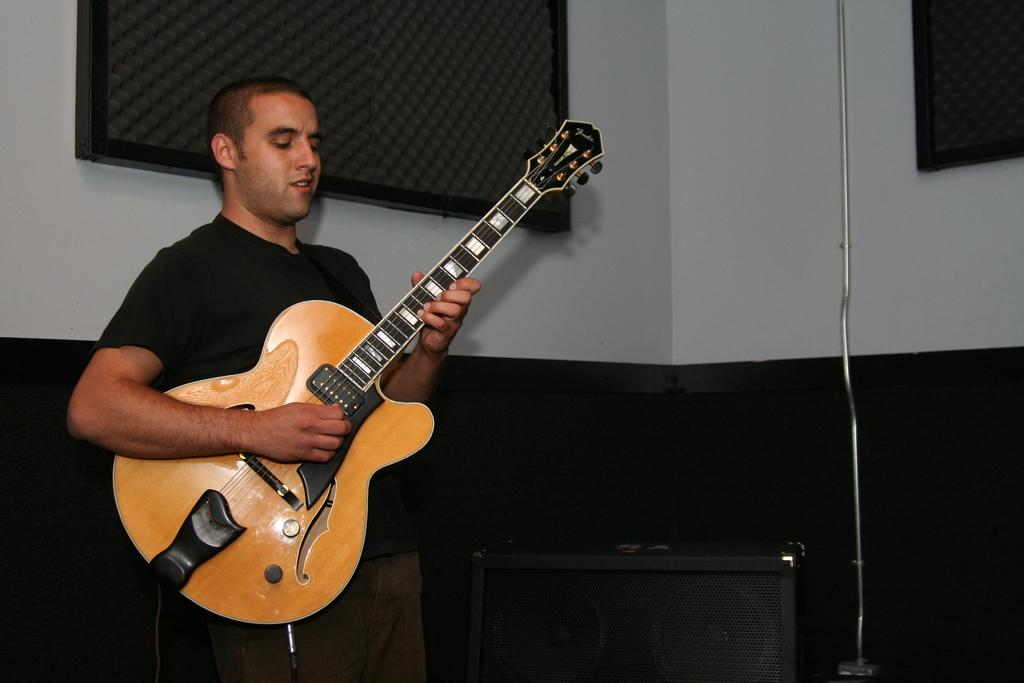What is the man in the image doing? The man is playing the guitar. What object is the man holding in the image? The man is holding a guitar. What is located beside the man in the image? There is a speaker beside the man. What can be seen in the background of the image? There is a wall in the background of the image. How many dogs are present in the image? There are no dogs present in the image. 